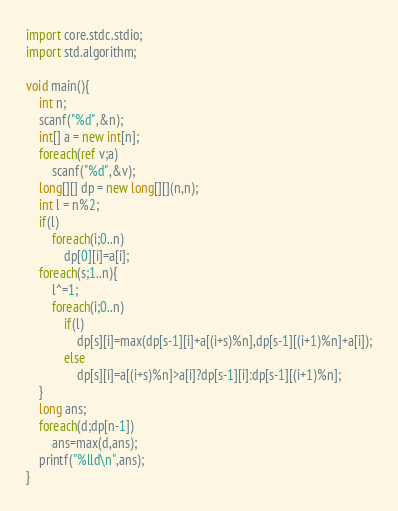Convert code to text. <code><loc_0><loc_0><loc_500><loc_500><_D_>import core.stdc.stdio;
import std.algorithm;

void main(){
	int n;
	scanf("%d",&n);
	int[] a = new int[n];
	foreach(ref v;a)
		scanf("%d",&v);
	long[][] dp = new long[][](n,n);
	int l = n%2;
	if(l)
		foreach(i;0..n)
			dp[0][i]=a[i];
	foreach(s;1..n){
		l^=1;
		foreach(i;0..n)
			if(l)
				dp[s][i]=max(dp[s-1][i]+a[(i+s)%n],dp[s-1][(i+1)%n]+a[i]);
			else
				dp[s][i]=a[(i+s)%n]>a[i]?dp[s-1][i]:dp[s-1][(i+1)%n];
	}
	long ans;
	foreach(d;dp[n-1])
		ans=max(d,ans);
	printf("%lld\n",ans);
}</code> 